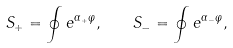Convert formula to latex. <formula><loc_0><loc_0><loc_500><loc_500>S _ { + } = \oint e ^ { \alpha _ { + } \varphi } , \quad S _ { - } = \oint e ^ { \alpha _ { - } \varphi } ,</formula> 